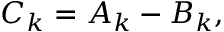<formula> <loc_0><loc_0><loc_500><loc_500>\begin{array} { r } { C _ { k } = A _ { k } - B _ { k } , } \end{array}</formula> 